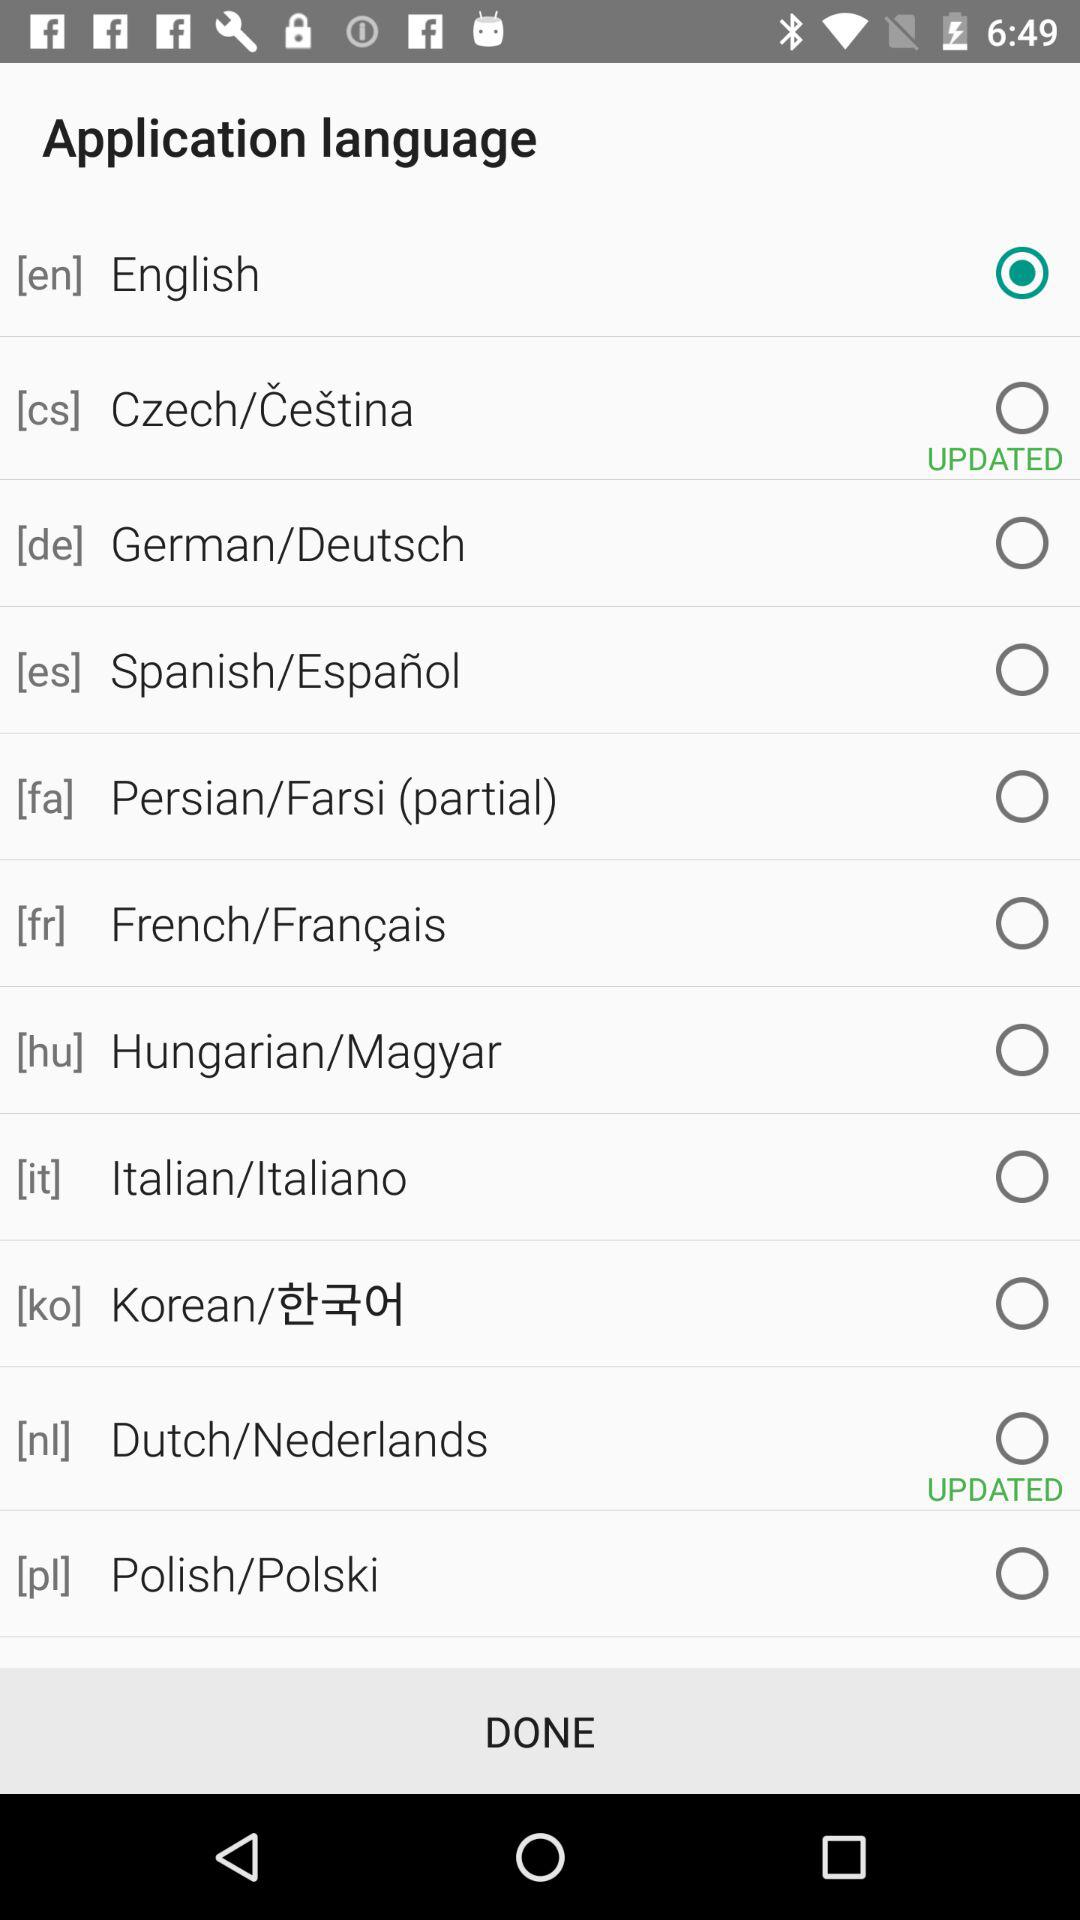What is the status of German/Deutsch? The status of German/Deutsch is "off". 